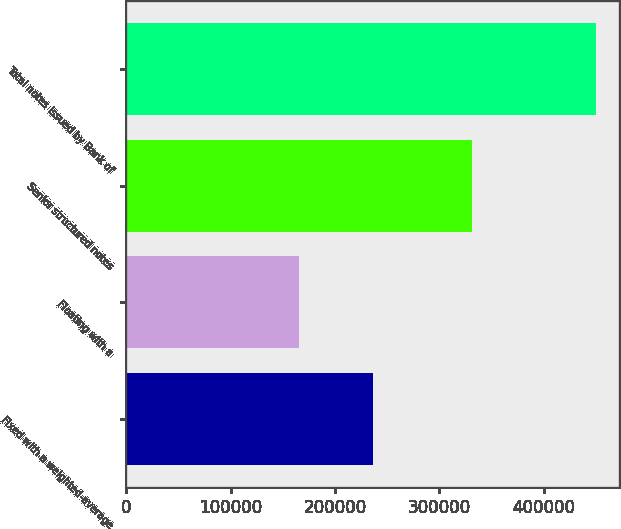<chart> <loc_0><loc_0><loc_500><loc_500><bar_chart><fcel>Fixed with a weighted-average<fcel>Floating with a<fcel>Senior structured notes<fcel>Total notes issued by Bank of<nl><fcel>236764<fcel>165744<fcel>331458<fcel>449825<nl></chart> 